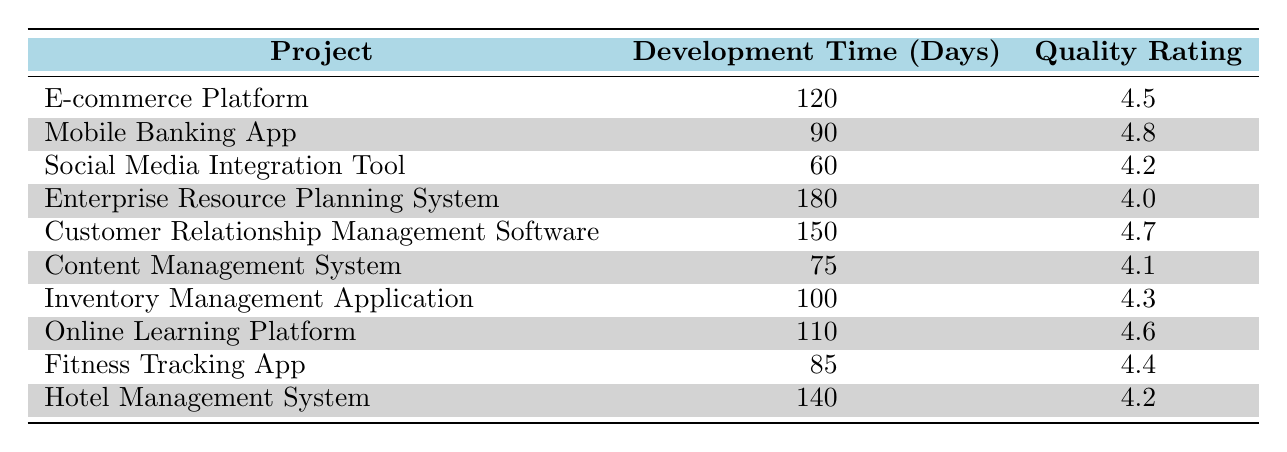What is the Product Quality Rating for the "Customer Relationship Management Software"? The table directly lists the Product Quality Rating for each project. We can find the "Customer Relationship Management Software" and see its rating of 4.7.
Answer: 4.7 Which project has the highest Development Time? By checking the Development Time column, we can identify that the "Enterprise Resource Planning System" has the highest Development Time at 180 days compared to the other projects.
Answer: Enterprise Resource Planning System What is the average Development Time of all projects listed? To find the average Development Time, we first sum the Development Times: 120 + 90 + 60 + 180 + 150 + 75 + 100 + 110 + 85 + 140 = 1,110. Then, divide by the number of projects, which is 10: 1110 / 10 = 111.
Answer: 111 Is the Product Quality Rating for the "Fitness Tracking App" higher than the rating for the "Social Media Integration Tool"? The rating for the "Fitness Tracking App" is 4.4 and for the "Social Media Integration Tool" it is 4.2. Since 4.4 is greater than 4.2, the statement is true.
Answer: Yes What is the difference in Development Time between the project with the lowest rating and the project with the highest rating? The project with the highest rating is "Mobile Banking App" with a rating of 4.8 and the lowest is "Enterprise Resource Planning System" with 4.0. The respective Development Times are 90 and 180 days. The difference is 180 - 90 = 90 days.
Answer: 90 How many projects have a Development Time less than 100 days? By reviewing the Development Time column, we find the following projects with less than 100 days: "Social Media Integration Tool" (60), "Content Management System" (75), and "Mobile Banking App" (90). That's a total of 3 projects.
Answer: 3 Are there any projects with the same Product Quality Rating, and if so, what are they? Checking the Product Quality Ratings in the table, we see no duplicate ratings. Each project's rating is unique.
Answer: No Which project has the highest Product Quality Rating and how long did it take to develop? The "Mobile Banking App" has the highest rating of 4.8. It took 90 days to develop. Thus, both the project name and its respective Development Time are relevant.
Answer: Mobile Banking App, 90 days 